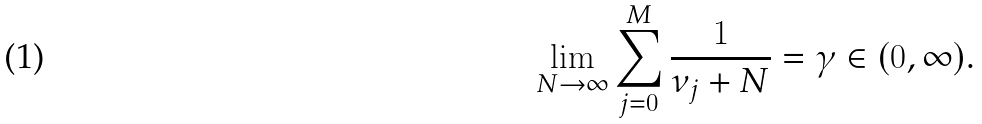Convert formula to latex. <formula><loc_0><loc_0><loc_500><loc_500>\lim _ { N \to \infty } \sum _ { j = 0 } ^ { M } \frac { 1 } { \nu _ { j } + N } = \gamma \in ( 0 , \infty ) .</formula> 